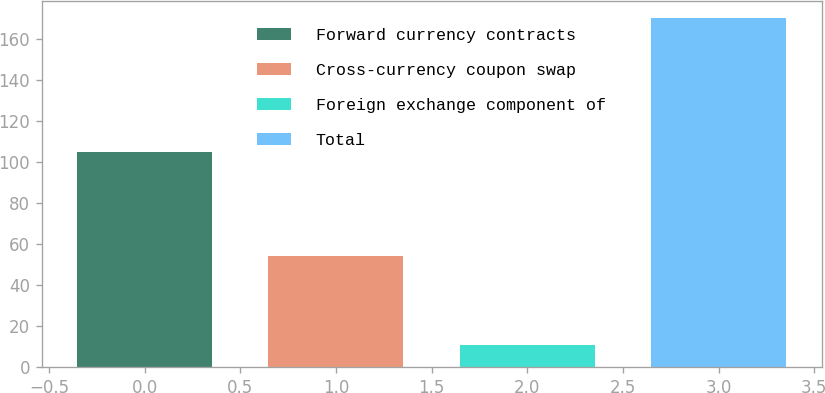Convert chart. <chart><loc_0><loc_0><loc_500><loc_500><bar_chart><fcel>Forward currency contracts<fcel>Cross-currency coupon swap<fcel>Foreign exchange component of<fcel>Total<nl><fcel>105<fcel>54<fcel>11<fcel>170<nl></chart> 